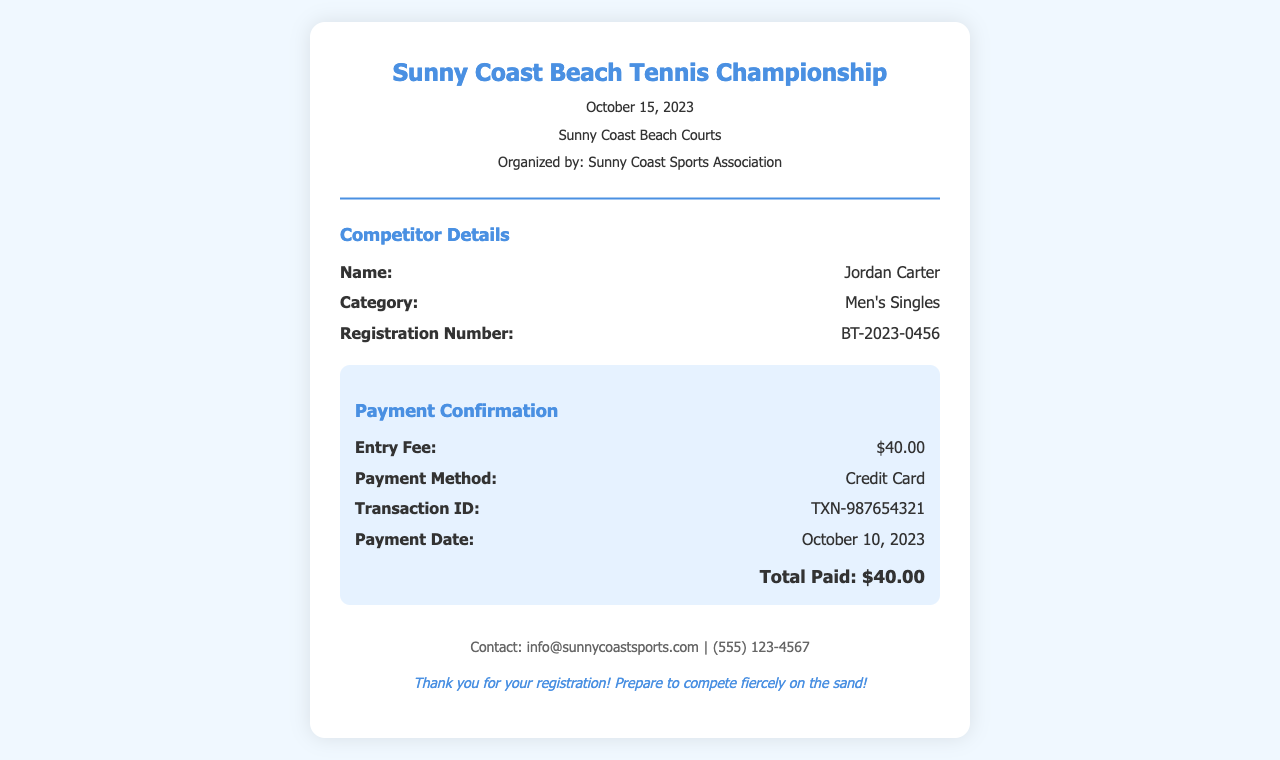What is the name of the event? The name of the event is stated in the header of the receipt.
Answer: Sunny Coast Beach Tennis Championship What is the date of the tournament? The date of the tournament is mentioned right below the event name.
Answer: October 15, 2023 Who is the competitor? The competitor's name is provided in the competitor details section.
Answer: Jordan Carter What is the registration number? The registration number is given in the competitor details section.
Answer: BT-2023-0456 How much is the entry fee? The entry fee is listed in the payment confirmation section.
Answer: $40.00 What payment method was used? The payment method is mentioned in the payment confirmation section.
Answer: Credit Card When was the payment made? The payment date is specified in the payment confirmation section.
Answer: October 10, 2023 What should competitors prepare for? The footer mentions what competitors should prepare for after registration.
Answer: Compete fiercely on the sand! 